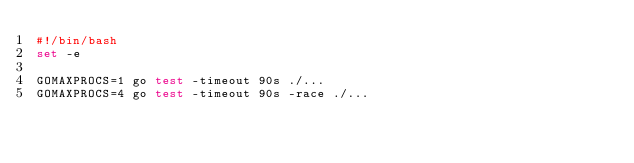<code> <loc_0><loc_0><loc_500><loc_500><_Bash_>#!/bin/bash
set -e

GOMAXPROCS=1 go test -timeout 90s ./...
GOMAXPROCS=4 go test -timeout 90s -race ./...
</code> 